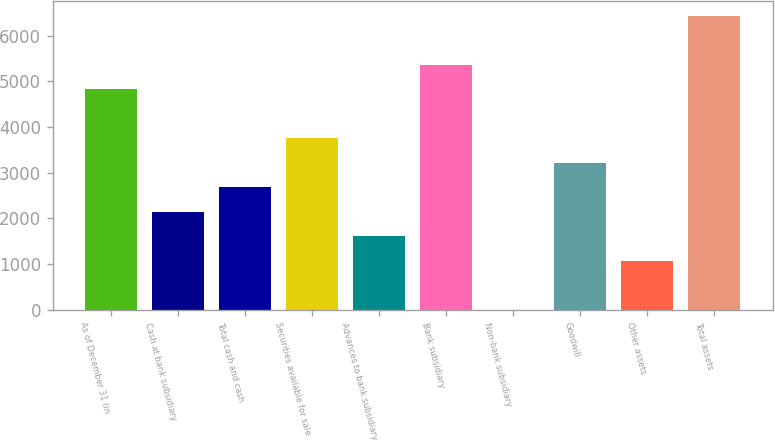Convert chart to OTSL. <chart><loc_0><loc_0><loc_500><loc_500><bar_chart><fcel>As of December 31 (in<fcel>Cash at bank subsidiary<fcel>Total cash and cash<fcel>Securities available for sale<fcel>Advances to bank subsidiary<fcel>Bank subsidiary<fcel>Non-bank subsidiary<fcel>Goodwill<fcel>Other assets<fcel>Total assets<nl><fcel>4822.28<fcel>2143.68<fcel>2679.4<fcel>3750.84<fcel>1607.96<fcel>5358<fcel>0.8<fcel>3215.12<fcel>1072.24<fcel>6429.44<nl></chart> 